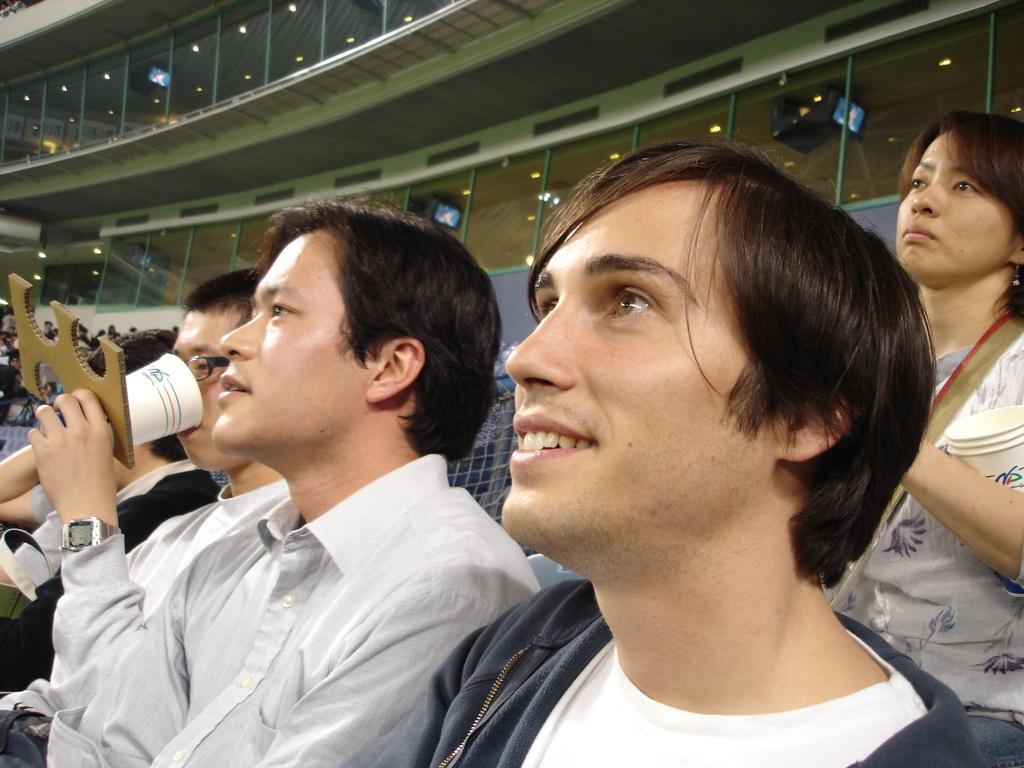In one or two sentences, can you explain what this image depicts? In this image there are people sitting on chairs, on the right side there is a woman standing, in the background there are glass windows. 